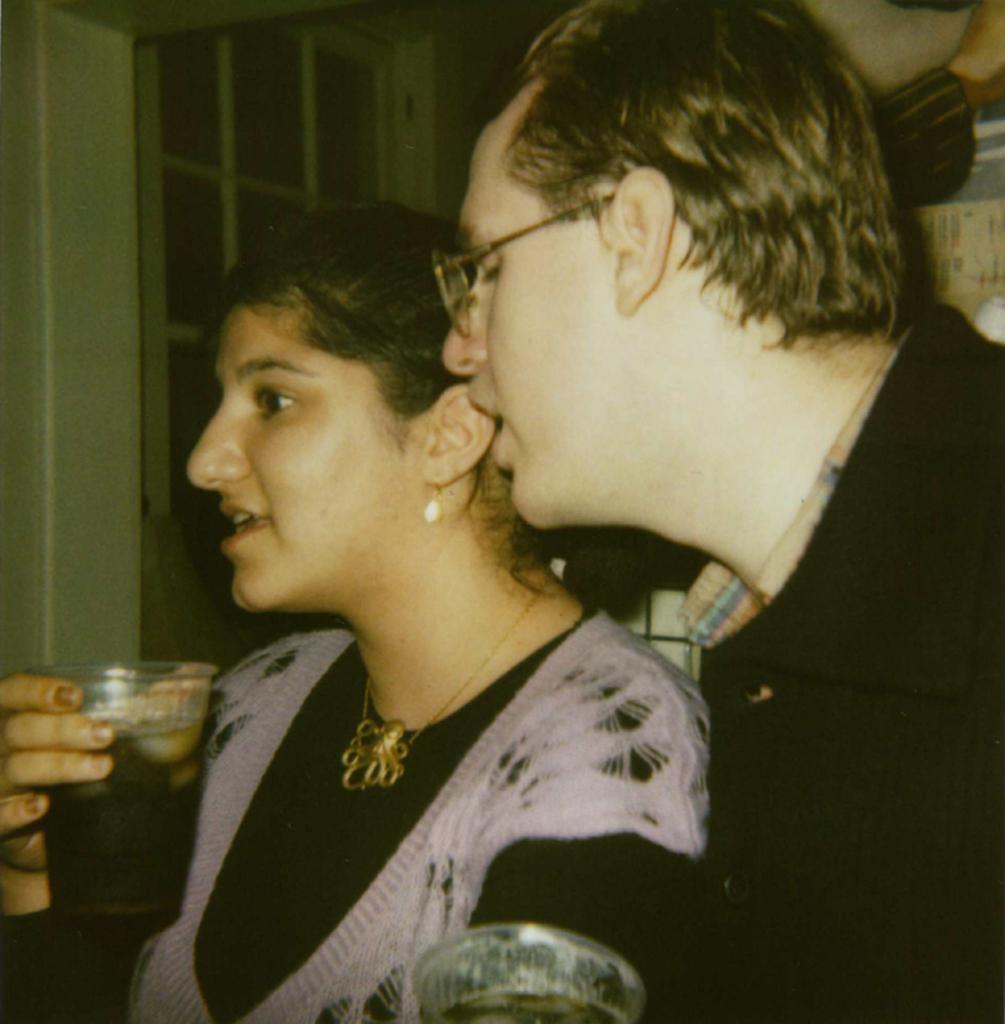Describe this image in one or two sentences. In this picture, we see a man is wearing the spectacles. Beside him, we see a woman is holding a glass containing the cool drink in her hand and she is trying to talk something. At the bottom, we see a cool drink glass. In the background, we see a wall and a window. This picture might be a photo frame. 